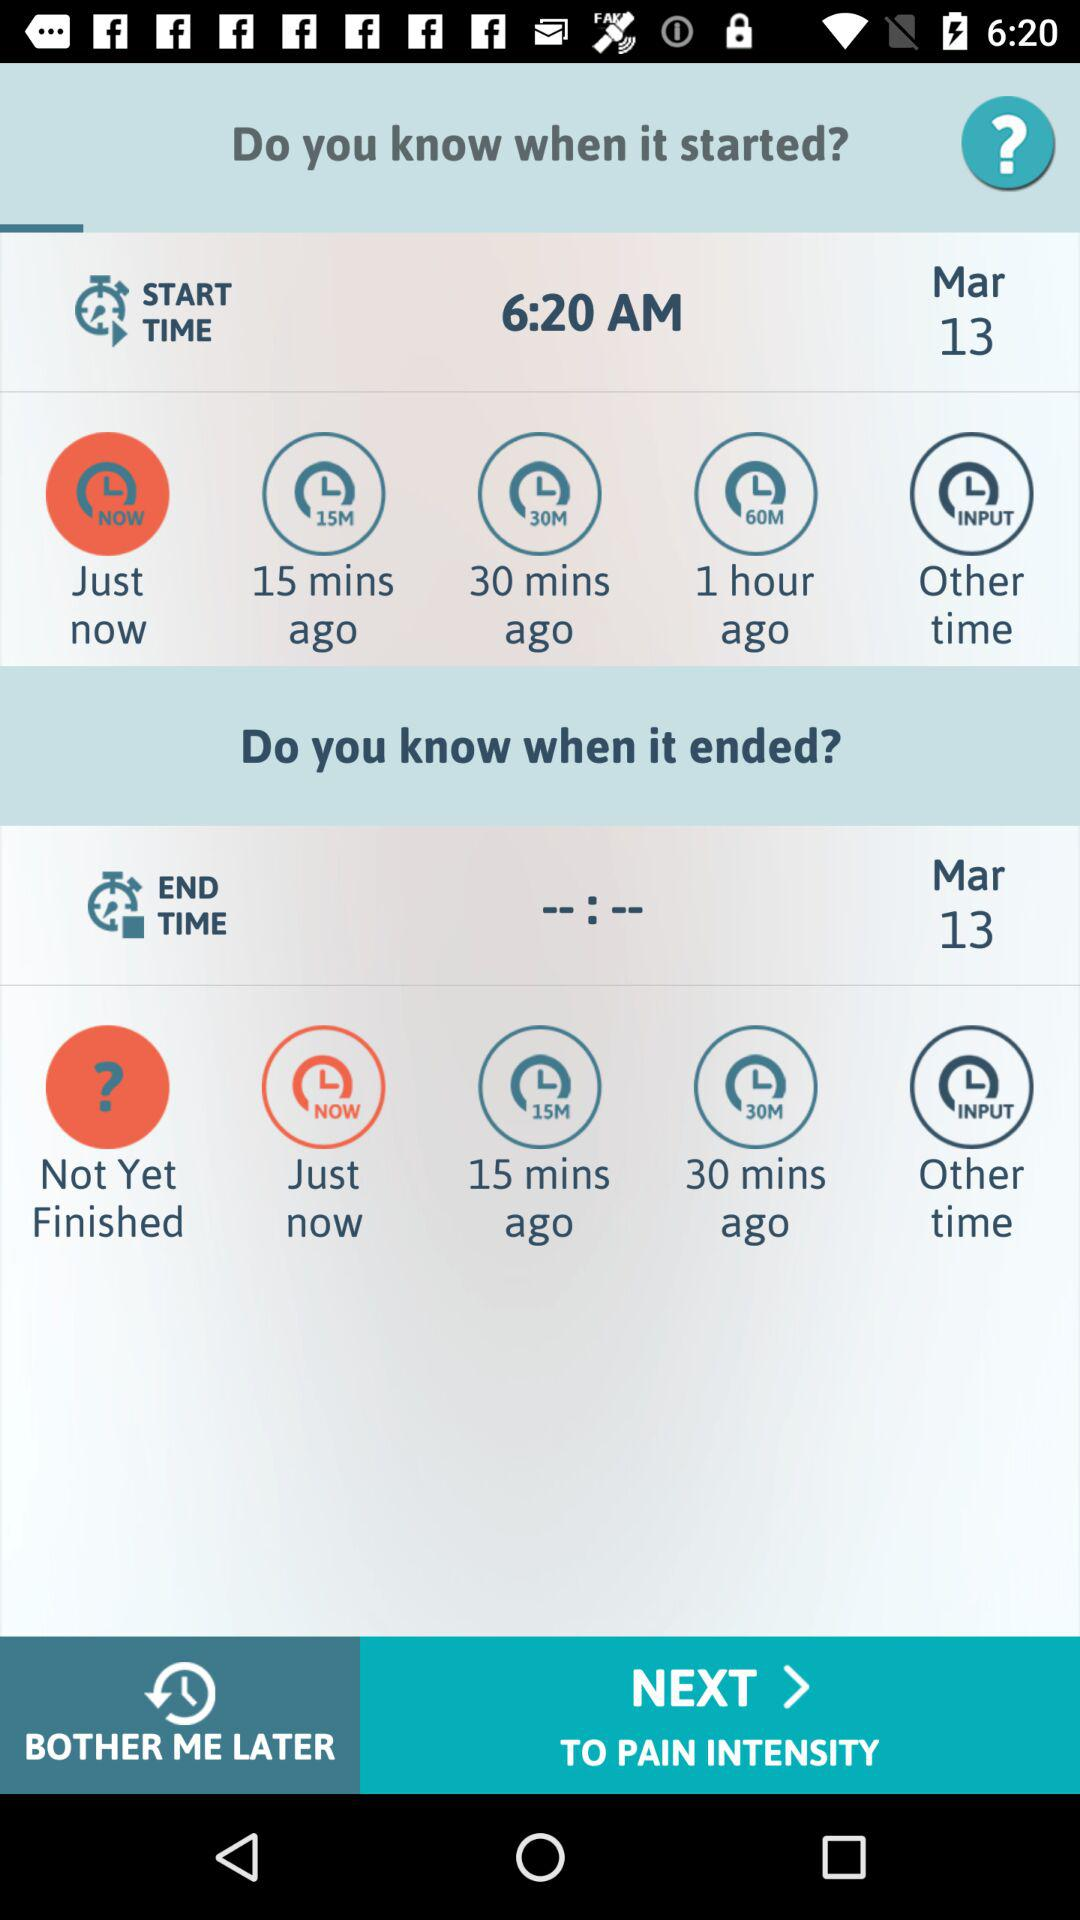Which option is selected in "Do you know when it ended?"? The selected option is "Not Yet Finished". 